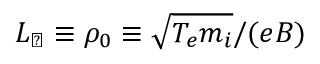Convert formula to latex. <formula><loc_0><loc_0><loc_500><loc_500>L _ { \perp } \equiv \rho _ { 0 } \equiv \sqrt { T _ { e } m _ { i } } / ( e B )</formula> 